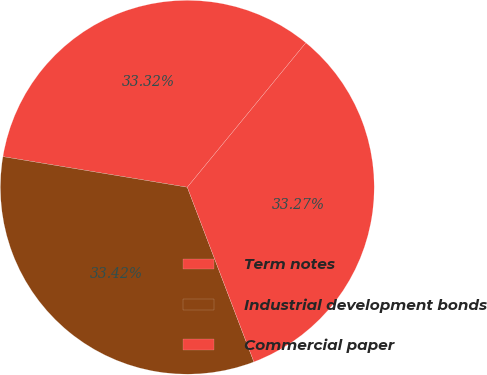<chart> <loc_0><loc_0><loc_500><loc_500><pie_chart><fcel>Term notes<fcel>Industrial development bonds<fcel>Commercial paper<nl><fcel>33.32%<fcel>33.42%<fcel>33.27%<nl></chart> 